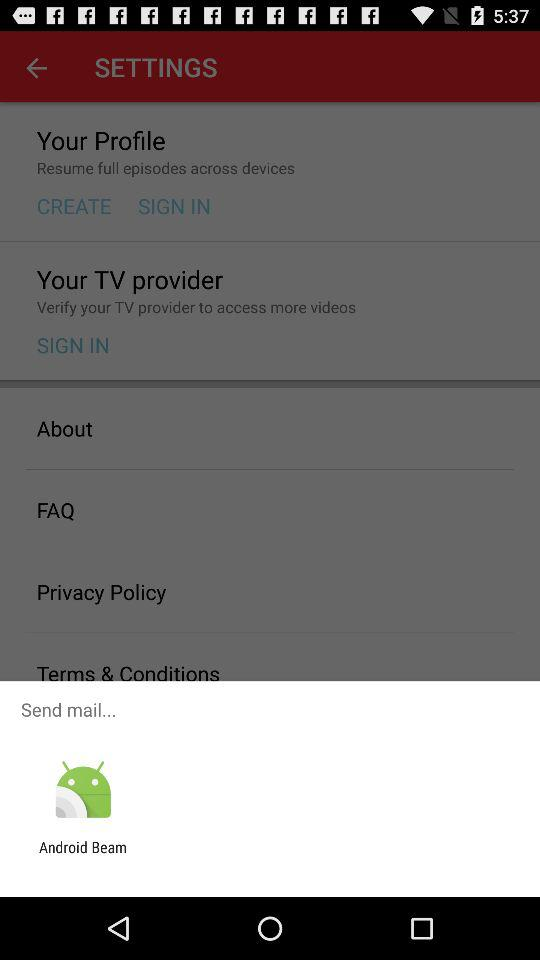What application is given for sending email? The application given for sending email is "Android Beam". 